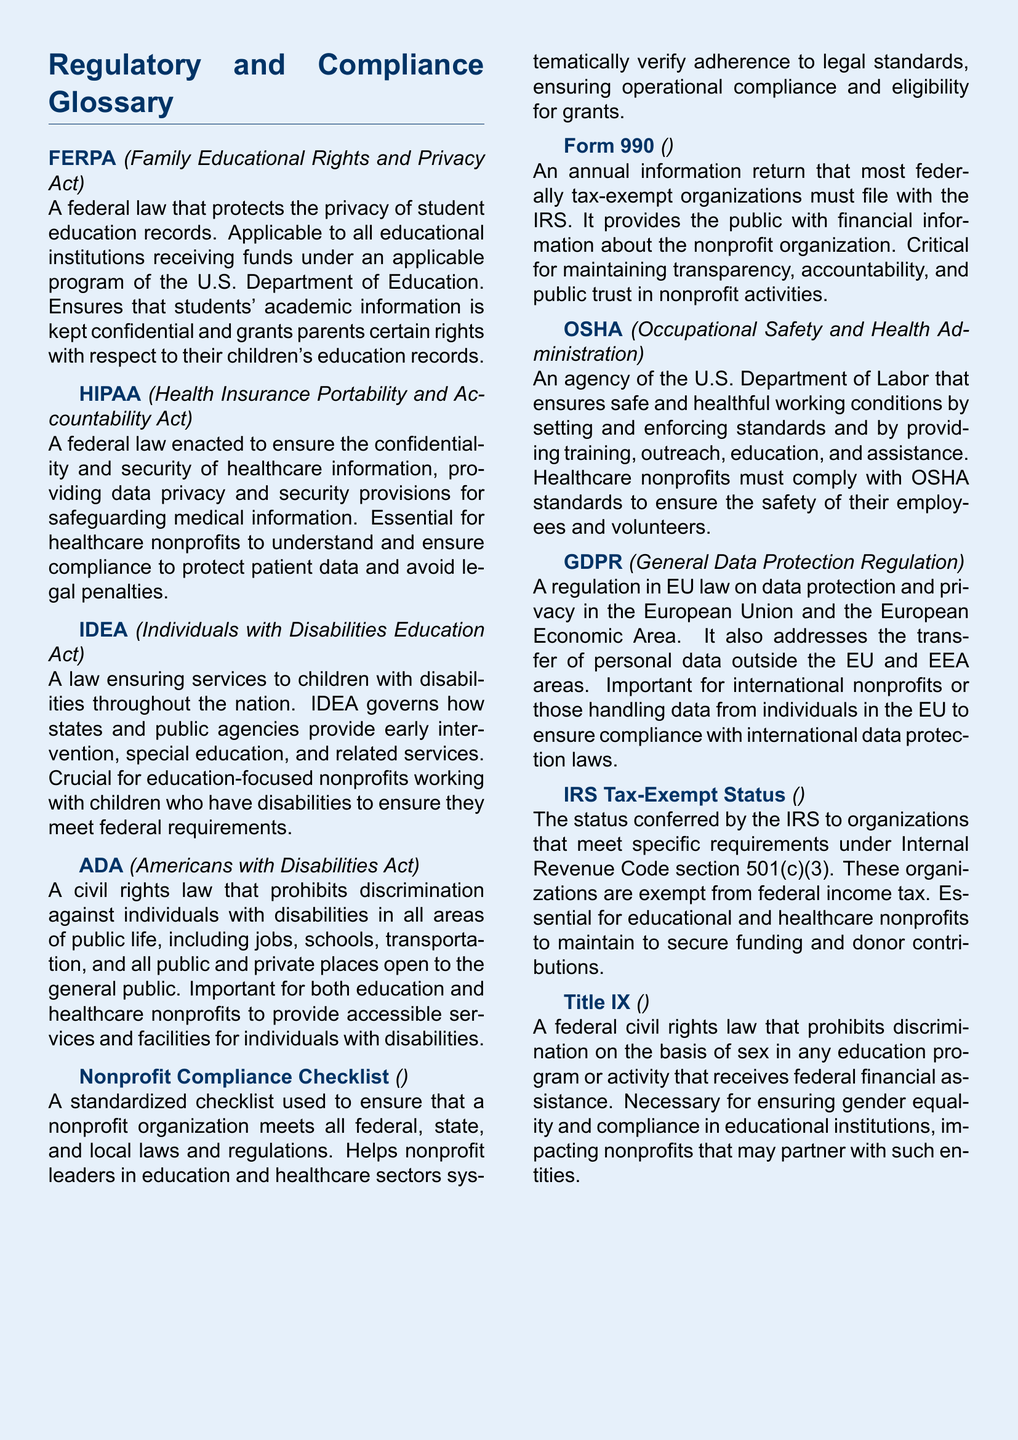What does FERPA stand for? FERPA is an acronym used in the document, specifically referring to a federal law regarding education records.
Answer: Family Educational Rights and Privacy Act What is the main purpose of HIPAA? HIPAA is defined in the document as a law that ensures confidentiality and security of healthcare information.
Answer: To ensure confidentiality and security of healthcare information Which act governs services to children with disabilities? The document explicitly mentions the act that ensures services to children with disabilities, providing critical information regarding education.
Answer: Individuals with Disabilities Education Act What does the acronym ADA represent? The document mentions ADA as a significant civil rights law without needing expansion; it is essential to know the meaning.
Answer: Americans with Disabilities Act What type of return must nonprofit organizations file with the IRS? The document states that there is a specific return that tax-exempt organizations must submit annually to maintain transparency.
Answer: Form 990 Why is OSHA important for healthcare nonprofits? The reason for OSHA's significance is explained in relation to its standards for safe working conditions.
Answer: To ensure the safety of their employees and volunteers What does GDPR regulate? The acronym GDPR is connected with regulations in the EU about data protection and privacy, as mentioned in the document.
Answer: Data protection and privacy What is the result of IRS Tax-Exempt Status? This term's explanation in the document indicates that organizations meeting certain requirements gain a specific standing with tax implications.
Answer: Exempt from federal income tax What does Title IX prohibit? According to the document, Title IX addresses discrimination based on a specific characteristic within educational programs.
Answer: Discrimination on the basis of sex What does a Nonprofit Compliance Checklist help verify? The checklist mentioned in the document is a tool for nonprofit organizations to confirm adherence to various regulations.
Answer: Adherence to legal standards 